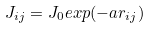Convert formula to latex. <formula><loc_0><loc_0><loc_500><loc_500>J _ { i j } = J _ { 0 } e x p ( - a r _ { i j } )</formula> 